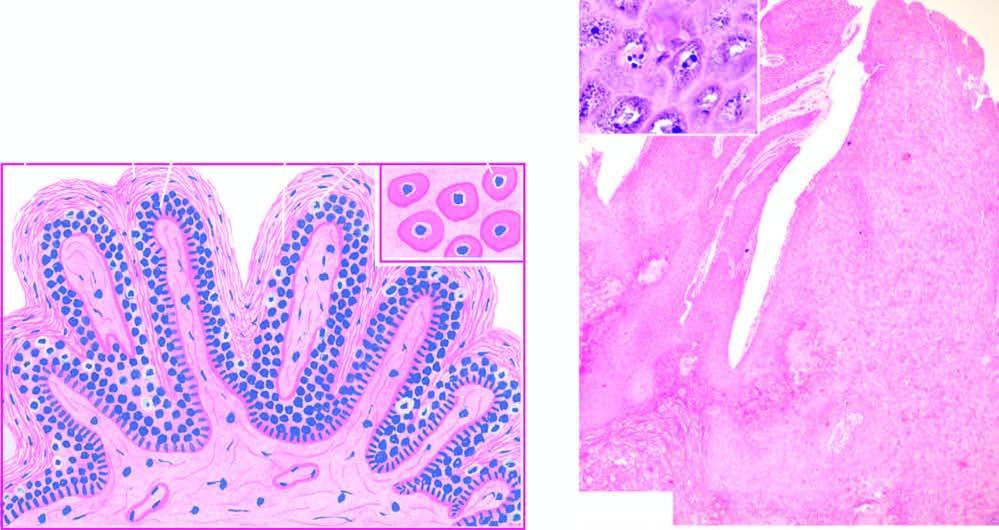did characteristic histologic features contain prominent keratohyaline granules?
Answer the question using a single word or phrase. No 